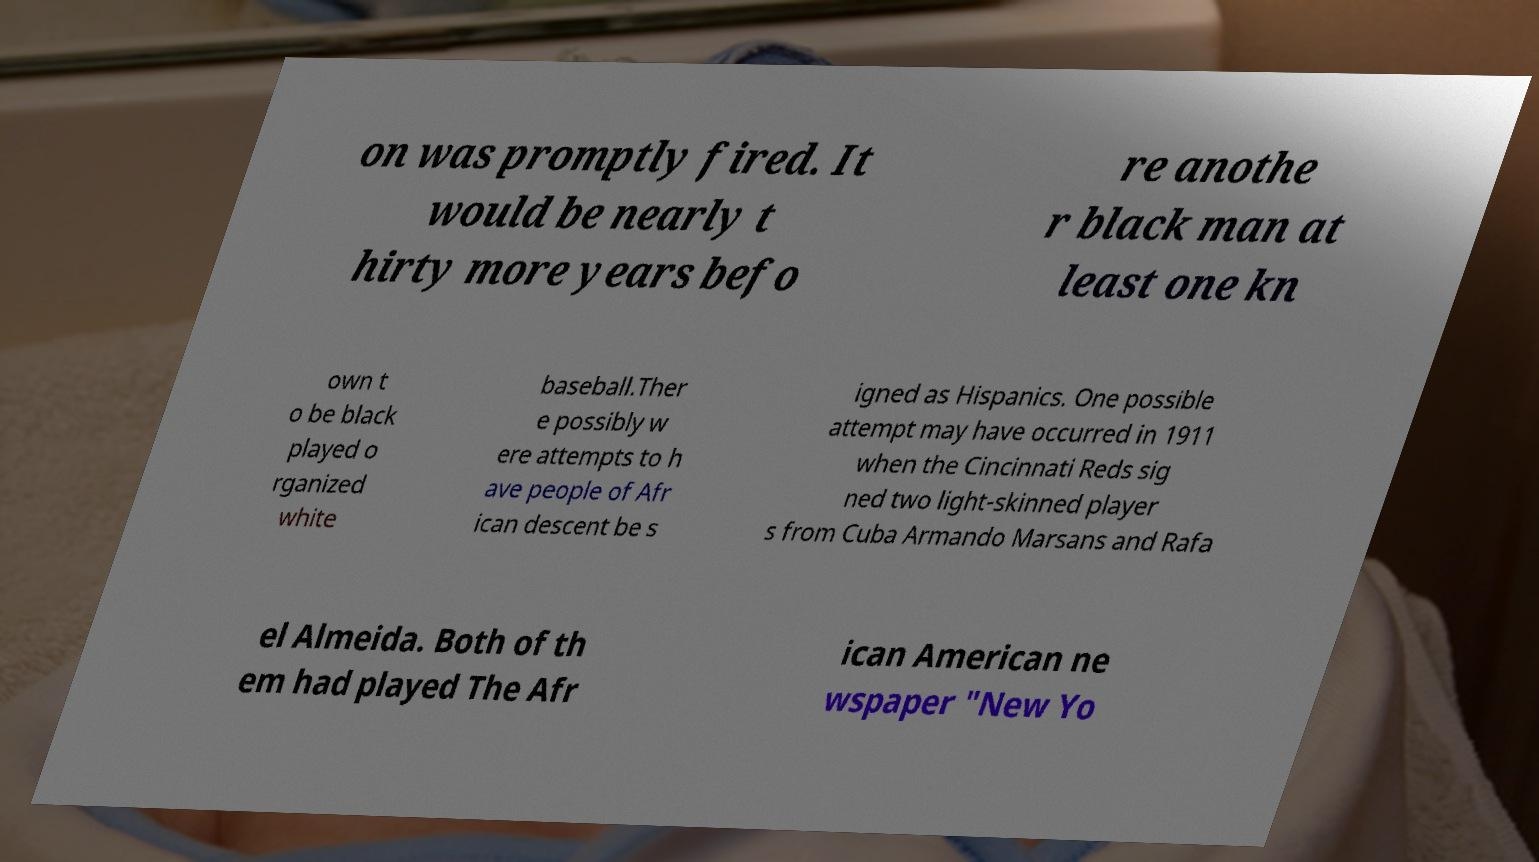Can you read and provide the text displayed in the image?This photo seems to have some interesting text. Can you extract and type it out for me? on was promptly fired. It would be nearly t hirty more years befo re anothe r black man at least one kn own t o be black played o rganized white baseball.Ther e possibly w ere attempts to h ave people of Afr ican descent be s igned as Hispanics. One possible attempt may have occurred in 1911 when the Cincinnati Reds sig ned two light-skinned player s from Cuba Armando Marsans and Rafa el Almeida. Both of th em had played The Afr ican American ne wspaper "New Yo 